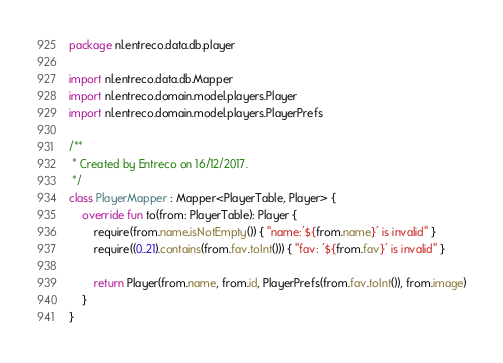Convert code to text. <code><loc_0><loc_0><loc_500><loc_500><_Kotlin_>package nl.entreco.data.db.player

import nl.entreco.data.db.Mapper
import nl.entreco.domain.model.players.Player
import nl.entreco.domain.model.players.PlayerPrefs

/**
 * Created by Entreco on 16/12/2017.
 */
class PlayerMapper : Mapper<PlayerTable, Player> {
    override fun to(from: PlayerTable): Player {
        require(from.name.isNotEmpty()) { "name:'${from.name}' is invalid" }
        require((0..21).contains(from.fav.toInt())) { "fav: '${from.fav}' is invalid" }

        return Player(from.name, from.id, PlayerPrefs(from.fav.toInt()), from.image)
    }
}
</code> 